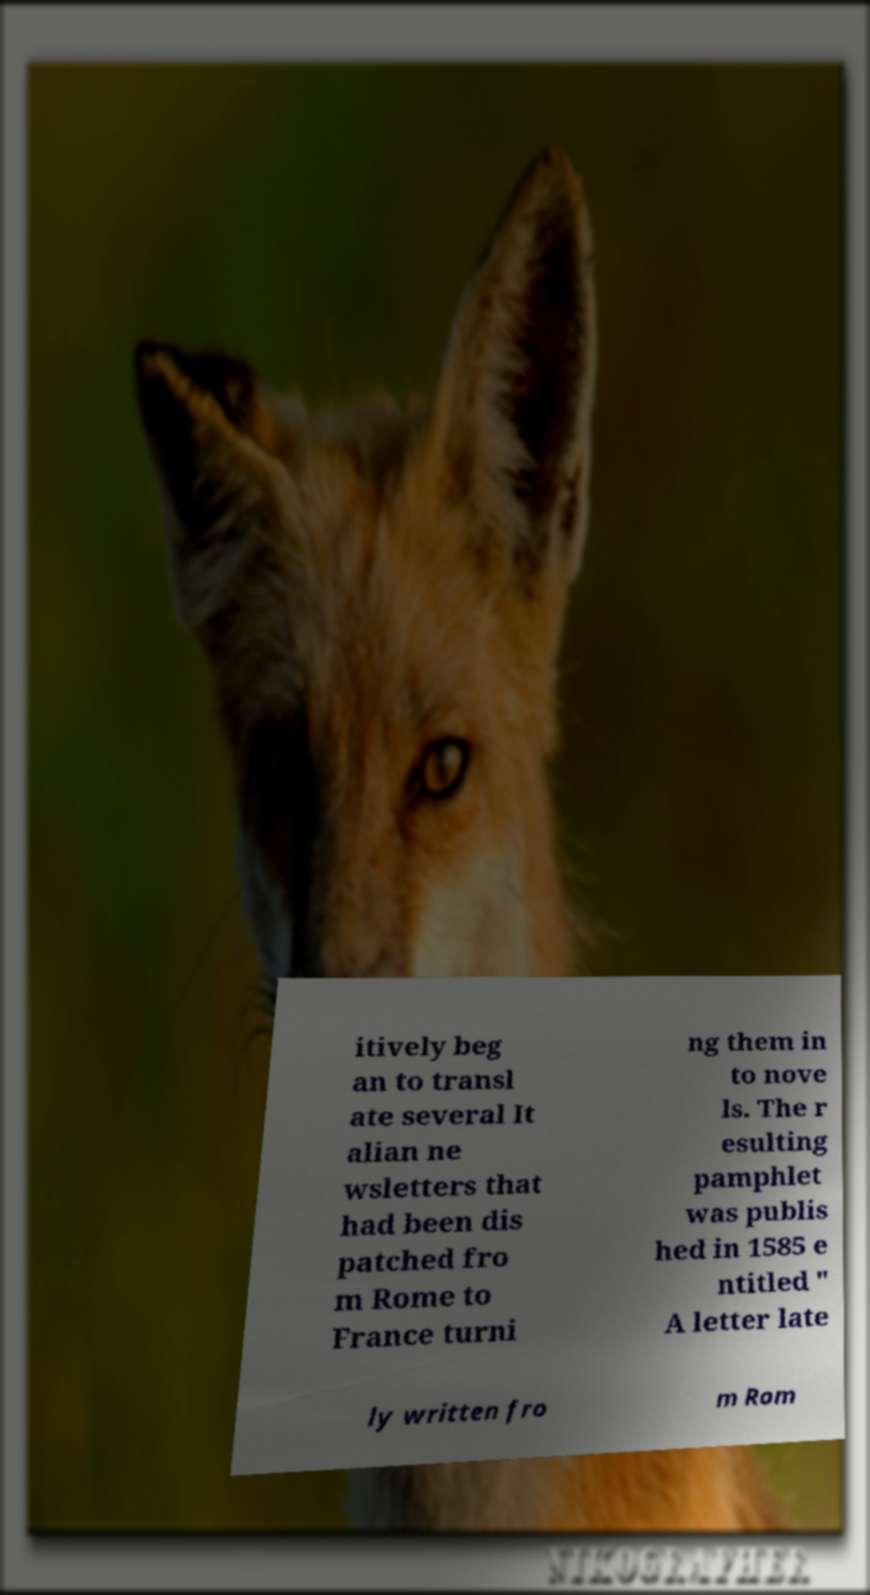Could you extract and type out the text from this image? itively beg an to transl ate several It alian ne wsletters that had been dis patched fro m Rome to France turni ng them in to nove ls. The r esulting pamphlet was publis hed in 1585 e ntitled " A letter late ly written fro m Rom 